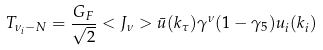Convert formula to latex. <formula><loc_0><loc_0><loc_500><loc_500>T _ { \nu _ { i } - N } = \frac { G _ { F } } { \sqrt { 2 } } < J _ { \nu } > \bar { u } ( k _ { \tau } ) \gamma ^ { \nu } ( 1 - \gamma _ { 5 } ) u _ { i } ( k _ { i } )</formula> 